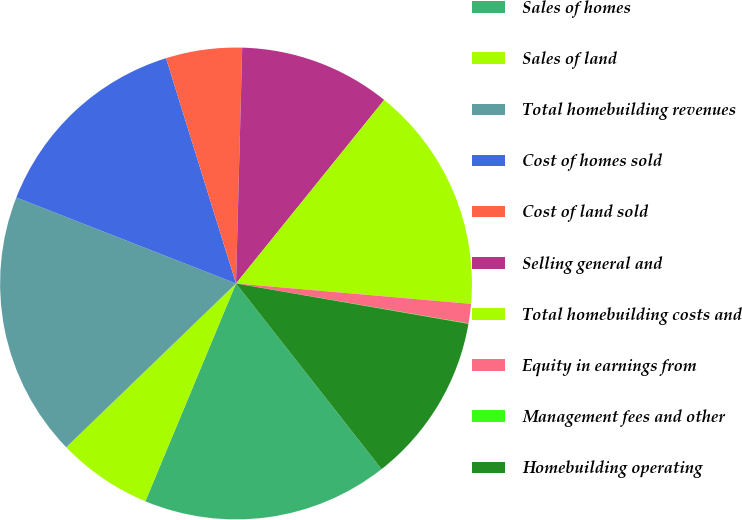Convert chart to OTSL. <chart><loc_0><loc_0><loc_500><loc_500><pie_chart><fcel>Sales of homes<fcel>Sales of land<fcel>Total homebuilding revenues<fcel>Cost of homes sold<fcel>Cost of land sold<fcel>Selling general and<fcel>Total homebuilding costs and<fcel>Equity in earnings from<fcel>Management fees and other<fcel>Homebuilding operating<nl><fcel>16.86%<fcel>6.51%<fcel>18.15%<fcel>14.27%<fcel>5.21%<fcel>10.39%<fcel>15.57%<fcel>1.33%<fcel>0.03%<fcel>11.68%<nl></chart> 